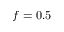<formula> <loc_0><loc_0><loc_500><loc_500>f = 0 . 5</formula> 